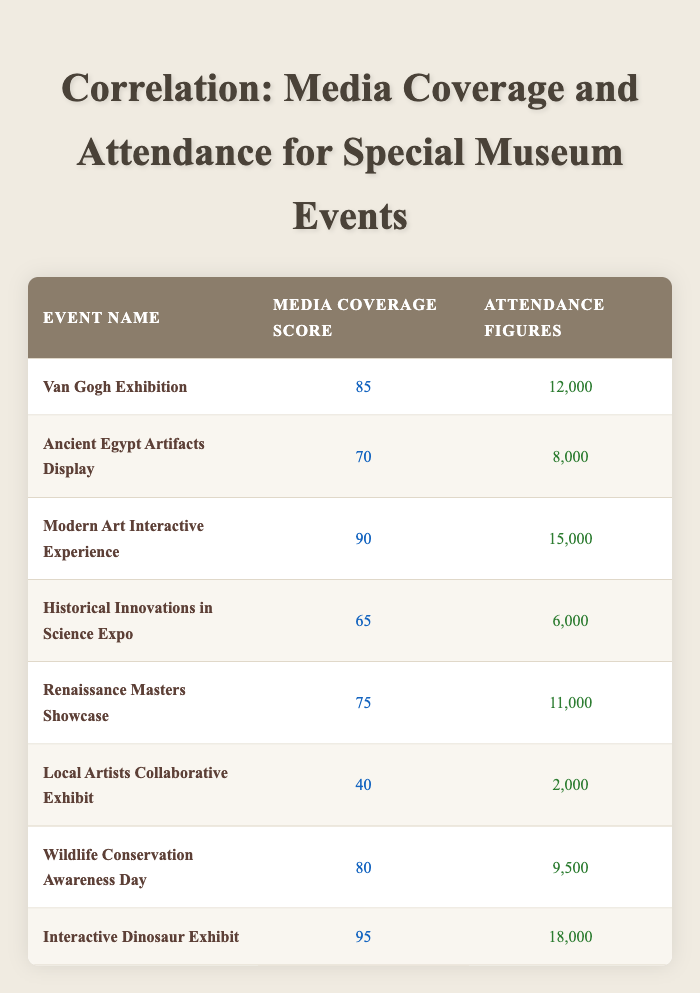What is the media coverage score for the Renaissance Masters Showcase? The table lists the Renaissance Masters Showcase with a media coverage score of 75.
Answer: 75 How many attendees did the Local Artists Collaborative Exhibit have? Referring to the table, the attendance figures for the Local Artists Collaborative Exhibit are 2,000.
Answer: 2,000 Which event had the highest media coverage score? By reviewing the table, the Interactive Dinosaur Exhibit has the highest score at 95.
Answer: 95 What is the total attendance for the events with a media coverage score of 80 or higher? For this calculation, we consider the events with scores of 80 or more: the Van Gogh Exhibition (12,000), Modern Art Interactive Experience (15,000), Wildlife Conservation Awareness Day (9,500), and Interactive Dinosaur Exhibit (18,000). Summing these gives us 12,000 + 15,000 + 9,500 + 18,000 = 54,500.
Answer: 54,500 Did the Ancient Egypt Artifacts Display have more attendees than the Historical Innovations in Science Expo? The attendance for the Ancient Egypt Artifacts Display is 8,000, while the Historical Innovations in Science Expo had 6,000. Since 8,000 is greater than 6,000, the statement is true.
Answer: Yes What is the difference in attendance between the event with the highest and lowest attendance figures? The highest attendance is 18,000 (Interactive Dinosaur Exhibit) and the lowest is 2,000 (Local Artists Collaborative Exhibit). The difference is 18,000 - 2,000 = 16,000.
Answer: 16,000 What is the average media coverage score for all events? To find the average, we sum all media coverage scores (85 + 70 + 90 + 65 + 75 + 40 + 80 + 95 = 600) and divide by the total number of events (8). So, the average is 600 / 8 = 75.
Answer: 75 Is it true that the number of attendees increases as the media coverage score increases? Analyzing the data, we see that events with higher scores like the Interactive Dinosaur Exhibit (95) and Modern Art Interactive Experience (90) have higher attendance than those with lower scores such as the Local Artists Collaborative Exhibit (40). Thus, generally, higher scores correspond with greater attendance, confirming the trend.
Answer: True 